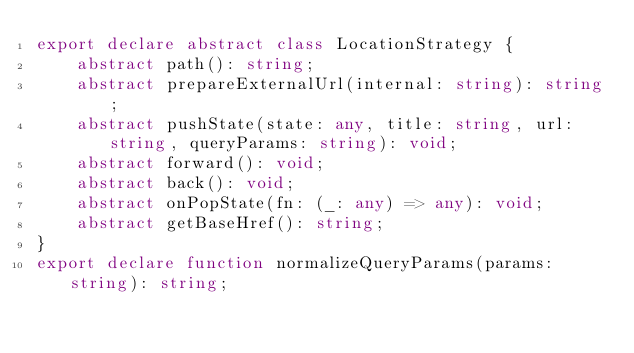Convert code to text. <code><loc_0><loc_0><loc_500><loc_500><_TypeScript_>export declare abstract class LocationStrategy {
    abstract path(): string;
    abstract prepareExternalUrl(internal: string): string;
    abstract pushState(state: any, title: string, url: string, queryParams: string): void;
    abstract forward(): void;
    abstract back(): void;
    abstract onPopState(fn: (_: any) => any): void;
    abstract getBaseHref(): string;
}
export declare function normalizeQueryParams(params: string): string;
</code> 